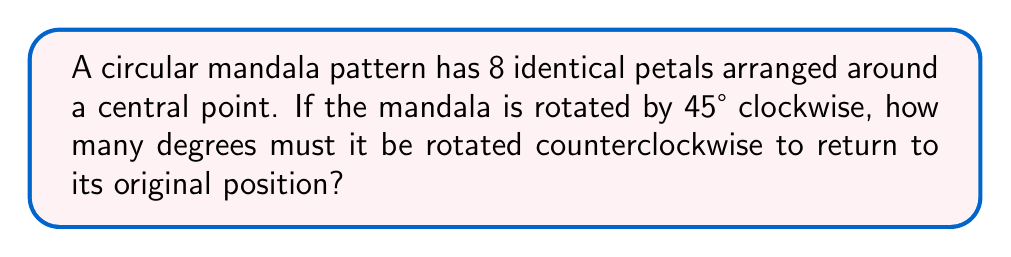Give your solution to this math problem. Let's approach this step-by-step:

1) First, we need to understand the symmetry of the mandala. With 8 identical petals, the mandala has 8-fold rotational symmetry.

2) This means that the mandala will look the same after rotations of 360°/8 = 45°.

3) The question states that the mandala is rotated 45° clockwise. We can represent this as a -45° rotation (negative because it's clockwise).

4) To return to the original position, we need to perform a rotation that, when combined with the -45° rotation, results in a total rotation that's a multiple of 360°.

5) Let's call our counterclockwise rotation $x$. We want:

   $$-45° + x = 360°n$$
   
   where $n$ is some integer.

6) The smallest positive value for $x$ that satisfies this equation is when $n = 1$:

   $$-45° + x = 360°$$
   $$x = 360° + 45° = 405°$$

7) However, we can simplify this further. Since 405° is more than a full rotation (360°), we can subtract 360°:

   $$405° - 360° = 45°$$

Therefore, a 45° counterclockwise rotation will return the mandala to its original position.
Answer: 45° 